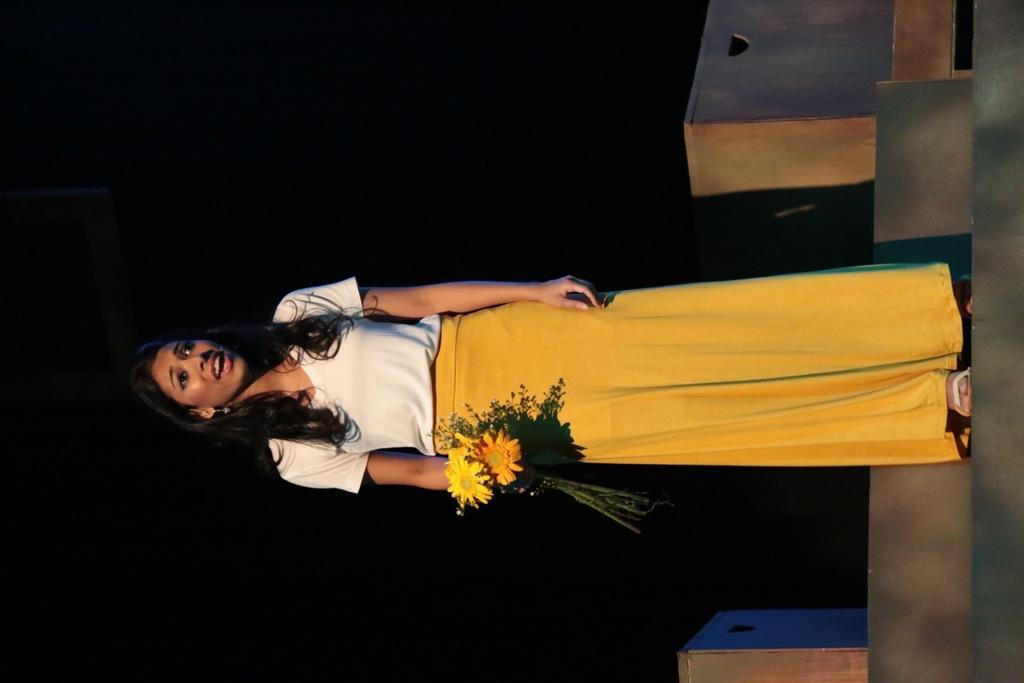In one or two sentences, can you explain what this image depicts? In the center of the image there is a lady holding flowers standing on the staircase. There are boxes. The background of the image is black in color. 